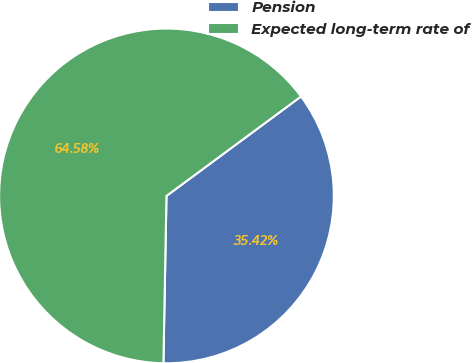Convert chart to OTSL. <chart><loc_0><loc_0><loc_500><loc_500><pie_chart><fcel>Pension<fcel>Expected long-term rate of<nl><fcel>35.42%<fcel>64.58%<nl></chart> 